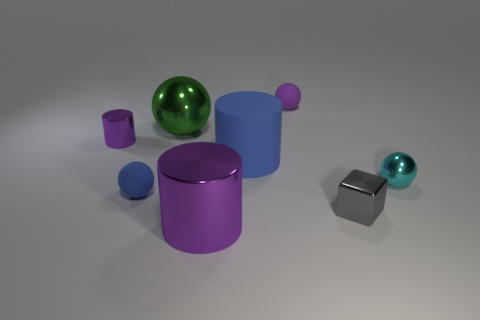Are there the same number of purple balls that are right of the grey shiny cube and grey objects? No, there is an unequal number of purple balls compared to gray objects. On the right of the gray shiny cube, there is one purple ball, while the total count of gray items is two, indicating an imbalance. 